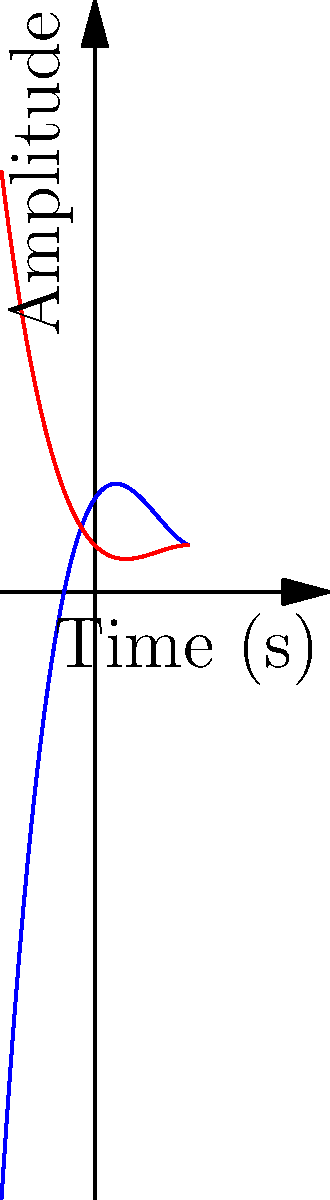You're analyzing two sound waves for your latest track. The blue curve represents Sound Wave A, modeled by the polynomial $f(x) = 0.5x^3 - 2x^2 + 1.5x + 2$, and the red curve represents Sound Wave B, modeled by $g(x) = -0.25x^3 + x^2 - x + 1$. At what point in time do these two sound waves have the same amplitude? To find the point where the two sound waves have the same amplitude, we need to solve the equation $f(x) = g(x)$. Let's approach this step-by-step:

1) Set up the equation:
   $0.5x^3 - 2x^2 + 1.5x + 2 = -0.25x^3 + x^2 - x + 1$

2) Rearrange all terms to one side:
   $0.75x^3 - 3x^2 + 2.5x + 1 = 0$

3) This is a cubic equation. While it can be solved algebraically, it's complex. In a real-world scenario, you'd likely use a graphing calculator or computational software.

4) Using such methods, we find that this equation has three solutions: $x ≈ -0.58$, $x ≈ 0.91$, and $x ≈ 3.01$.

5) Looking at our graph, we can see that the curves intersect within the visible range at $x ≈ 0.91$.

Therefore, the sound waves have the same amplitude at approximately 0.91 seconds.
Answer: 0.91 seconds 